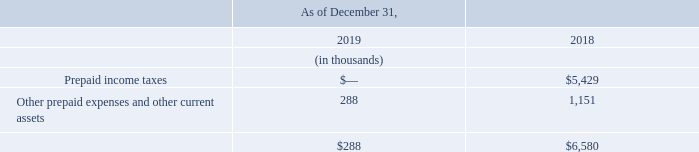NOTE 4 - PREPAID EXPENSES AND OTHER CURRENT ASSETS & PATENTS AND INTANGIBLE ASSETS
Prepaid Expenses and Other Current Assets
The components of prepaid expenses and other current assets are as presented below:
During 2019, tax refunds from the Internal Revenue Service of $5.0 million were received for the prepayment made during 2018.
What is the value of tax refunds from the Internal Revenue Service in 2019? $5.0 million. What are the respective prepaid income taxes in 2019 and 2018?
Answer scale should be: thousand. 0, 5,429. What are the respective values of other prepaid expenses and other current assets in 2019 and 2018?
Answer scale should be: thousand. 288, 1,151. What is the average value of total paid expenses and other current assets in 2018 and 2019?
Answer scale should be: thousand. (288 + 6,580)/2 
Answer: 3434. What is the value of the prepaid income taxes as a percentage of the total prepaid expenses and other current assets in 2018?
Answer scale should be: percent. 5,429/6,580 
Answer: 82.51. What is the percentage change in other prepaid expenses and other current assets between 2018 and 2019?
Answer scale should be: percent. (288 - 1,151)/1,151 
Answer: -74.98. 